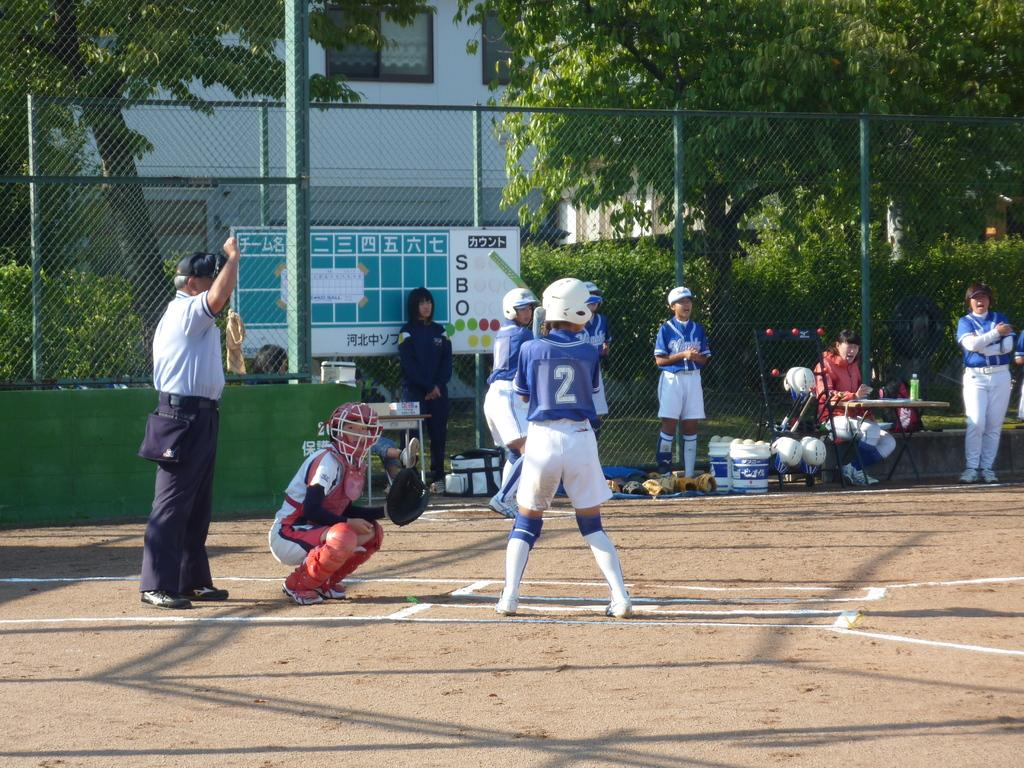<image>
Offer a succinct explanation of the picture presented. A sports game which shows a man wearing a number 2 shirt. 